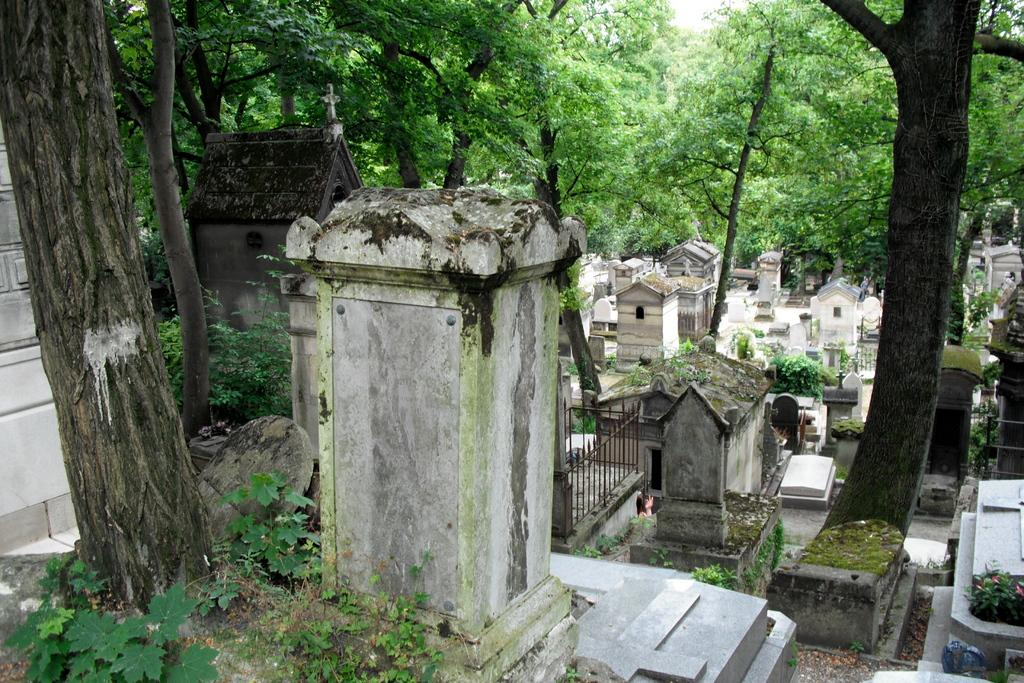What is the location of the image? The image is taken in a graveyard. What can be seen in the graveyard? There are graves in the image. What type of vegetation is present in the image? There are trees in the image. How many fish are swimming in the graveyard in the image? There are no fish present in the image, as it is taken in a graveyard and not an aquatic environment. 